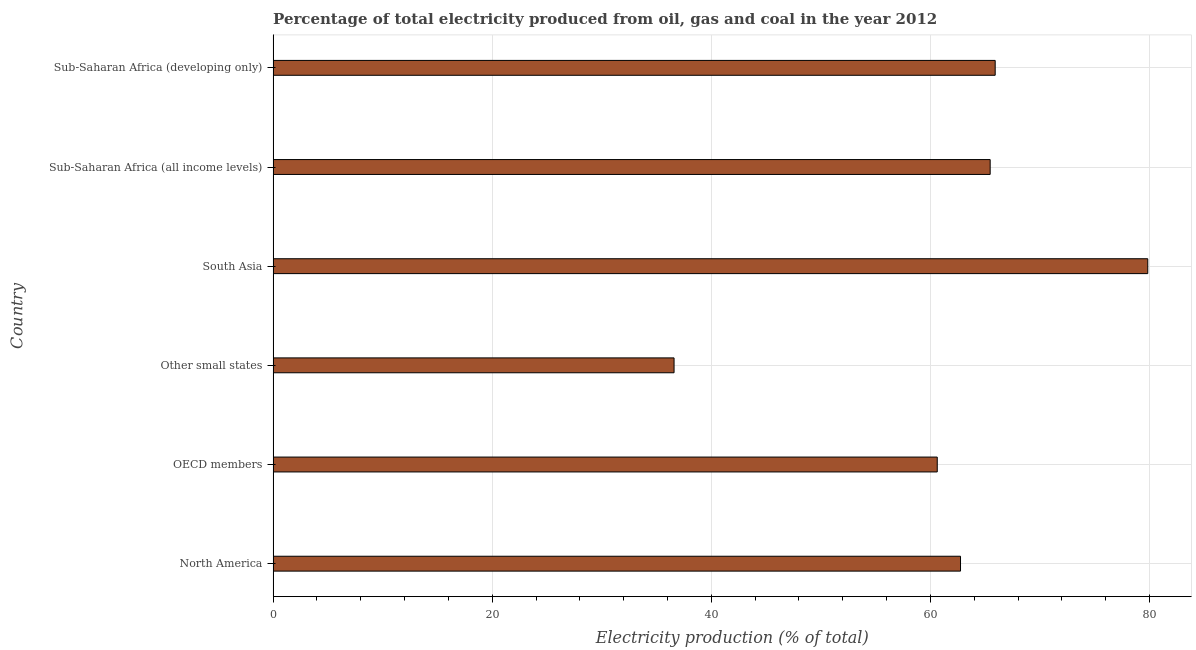What is the title of the graph?
Offer a very short reply. Percentage of total electricity produced from oil, gas and coal in the year 2012. What is the label or title of the X-axis?
Give a very brief answer. Electricity production (% of total). What is the label or title of the Y-axis?
Make the answer very short. Country. What is the electricity production in South Asia?
Give a very brief answer. 79.84. Across all countries, what is the maximum electricity production?
Keep it short and to the point. 79.84. Across all countries, what is the minimum electricity production?
Provide a succinct answer. 36.6. In which country was the electricity production minimum?
Keep it short and to the point. Other small states. What is the sum of the electricity production?
Keep it short and to the point. 371.19. What is the difference between the electricity production in Sub-Saharan Africa (all income levels) and Sub-Saharan Africa (developing only)?
Keep it short and to the point. -0.46. What is the average electricity production per country?
Offer a very short reply. 61.87. What is the median electricity production?
Make the answer very short. 64.1. In how many countries, is the electricity production greater than 32 %?
Your response must be concise. 6. Is the difference between the electricity production in North America and Sub-Saharan Africa (developing only) greater than the difference between any two countries?
Your answer should be very brief. No. What is the difference between the highest and the second highest electricity production?
Provide a short and direct response. 13.93. Is the sum of the electricity production in South Asia and Sub-Saharan Africa (developing only) greater than the maximum electricity production across all countries?
Offer a terse response. Yes. What is the difference between the highest and the lowest electricity production?
Offer a terse response. 43.24. How many bars are there?
Your answer should be compact. 6. Are all the bars in the graph horizontal?
Give a very brief answer. Yes. How many countries are there in the graph?
Provide a short and direct response. 6. What is the difference between two consecutive major ticks on the X-axis?
Your answer should be very brief. 20. Are the values on the major ticks of X-axis written in scientific E-notation?
Ensure brevity in your answer.  No. What is the Electricity production (% of total) in North America?
Make the answer very short. 62.75. What is the Electricity production (% of total) in OECD members?
Your answer should be compact. 60.63. What is the Electricity production (% of total) of Other small states?
Ensure brevity in your answer.  36.6. What is the Electricity production (% of total) of South Asia?
Offer a very short reply. 79.84. What is the Electricity production (% of total) of Sub-Saharan Africa (all income levels)?
Give a very brief answer. 65.46. What is the Electricity production (% of total) in Sub-Saharan Africa (developing only)?
Your answer should be compact. 65.92. What is the difference between the Electricity production (% of total) in North America and OECD members?
Provide a succinct answer. 2.12. What is the difference between the Electricity production (% of total) in North America and Other small states?
Offer a very short reply. 26.15. What is the difference between the Electricity production (% of total) in North America and South Asia?
Offer a terse response. -17.09. What is the difference between the Electricity production (% of total) in North America and Sub-Saharan Africa (all income levels)?
Your response must be concise. -2.71. What is the difference between the Electricity production (% of total) in North America and Sub-Saharan Africa (developing only)?
Provide a short and direct response. -3.17. What is the difference between the Electricity production (% of total) in OECD members and Other small states?
Provide a short and direct response. 24.02. What is the difference between the Electricity production (% of total) in OECD members and South Asia?
Keep it short and to the point. -19.22. What is the difference between the Electricity production (% of total) in OECD members and Sub-Saharan Africa (all income levels)?
Provide a short and direct response. -4.83. What is the difference between the Electricity production (% of total) in OECD members and Sub-Saharan Africa (developing only)?
Provide a short and direct response. -5.29. What is the difference between the Electricity production (% of total) in Other small states and South Asia?
Your answer should be very brief. -43.24. What is the difference between the Electricity production (% of total) in Other small states and Sub-Saharan Africa (all income levels)?
Give a very brief answer. -28.86. What is the difference between the Electricity production (% of total) in Other small states and Sub-Saharan Africa (developing only)?
Offer a terse response. -29.31. What is the difference between the Electricity production (% of total) in South Asia and Sub-Saharan Africa (all income levels)?
Provide a short and direct response. 14.39. What is the difference between the Electricity production (% of total) in South Asia and Sub-Saharan Africa (developing only)?
Offer a very short reply. 13.93. What is the difference between the Electricity production (% of total) in Sub-Saharan Africa (all income levels) and Sub-Saharan Africa (developing only)?
Offer a very short reply. -0.46. What is the ratio of the Electricity production (% of total) in North America to that in OECD members?
Offer a very short reply. 1.03. What is the ratio of the Electricity production (% of total) in North America to that in Other small states?
Give a very brief answer. 1.71. What is the ratio of the Electricity production (% of total) in North America to that in South Asia?
Provide a succinct answer. 0.79. What is the ratio of the Electricity production (% of total) in North America to that in Sub-Saharan Africa (developing only)?
Keep it short and to the point. 0.95. What is the ratio of the Electricity production (% of total) in OECD members to that in Other small states?
Provide a succinct answer. 1.66. What is the ratio of the Electricity production (% of total) in OECD members to that in South Asia?
Give a very brief answer. 0.76. What is the ratio of the Electricity production (% of total) in OECD members to that in Sub-Saharan Africa (all income levels)?
Keep it short and to the point. 0.93. What is the ratio of the Electricity production (% of total) in Other small states to that in South Asia?
Offer a very short reply. 0.46. What is the ratio of the Electricity production (% of total) in Other small states to that in Sub-Saharan Africa (all income levels)?
Make the answer very short. 0.56. What is the ratio of the Electricity production (% of total) in Other small states to that in Sub-Saharan Africa (developing only)?
Offer a terse response. 0.56. What is the ratio of the Electricity production (% of total) in South Asia to that in Sub-Saharan Africa (all income levels)?
Keep it short and to the point. 1.22. What is the ratio of the Electricity production (% of total) in South Asia to that in Sub-Saharan Africa (developing only)?
Offer a very short reply. 1.21. 